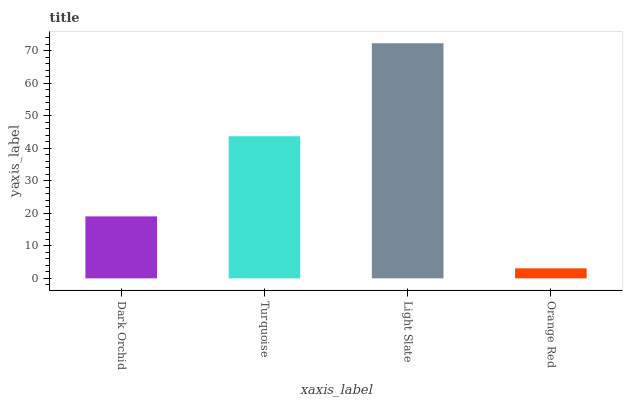Is Orange Red the minimum?
Answer yes or no. Yes. Is Light Slate the maximum?
Answer yes or no. Yes. Is Turquoise the minimum?
Answer yes or no. No. Is Turquoise the maximum?
Answer yes or no. No. Is Turquoise greater than Dark Orchid?
Answer yes or no. Yes. Is Dark Orchid less than Turquoise?
Answer yes or no. Yes. Is Dark Orchid greater than Turquoise?
Answer yes or no. No. Is Turquoise less than Dark Orchid?
Answer yes or no. No. Is Turquoise the high median?
Answer yes or no. Yes. Is Dark Orchid the low median?
Answer yes or no. Yes. Is Orange Red the high median?
Answer yes or no. No. Is Light Slate the low median?
Answer yes or no. No. 